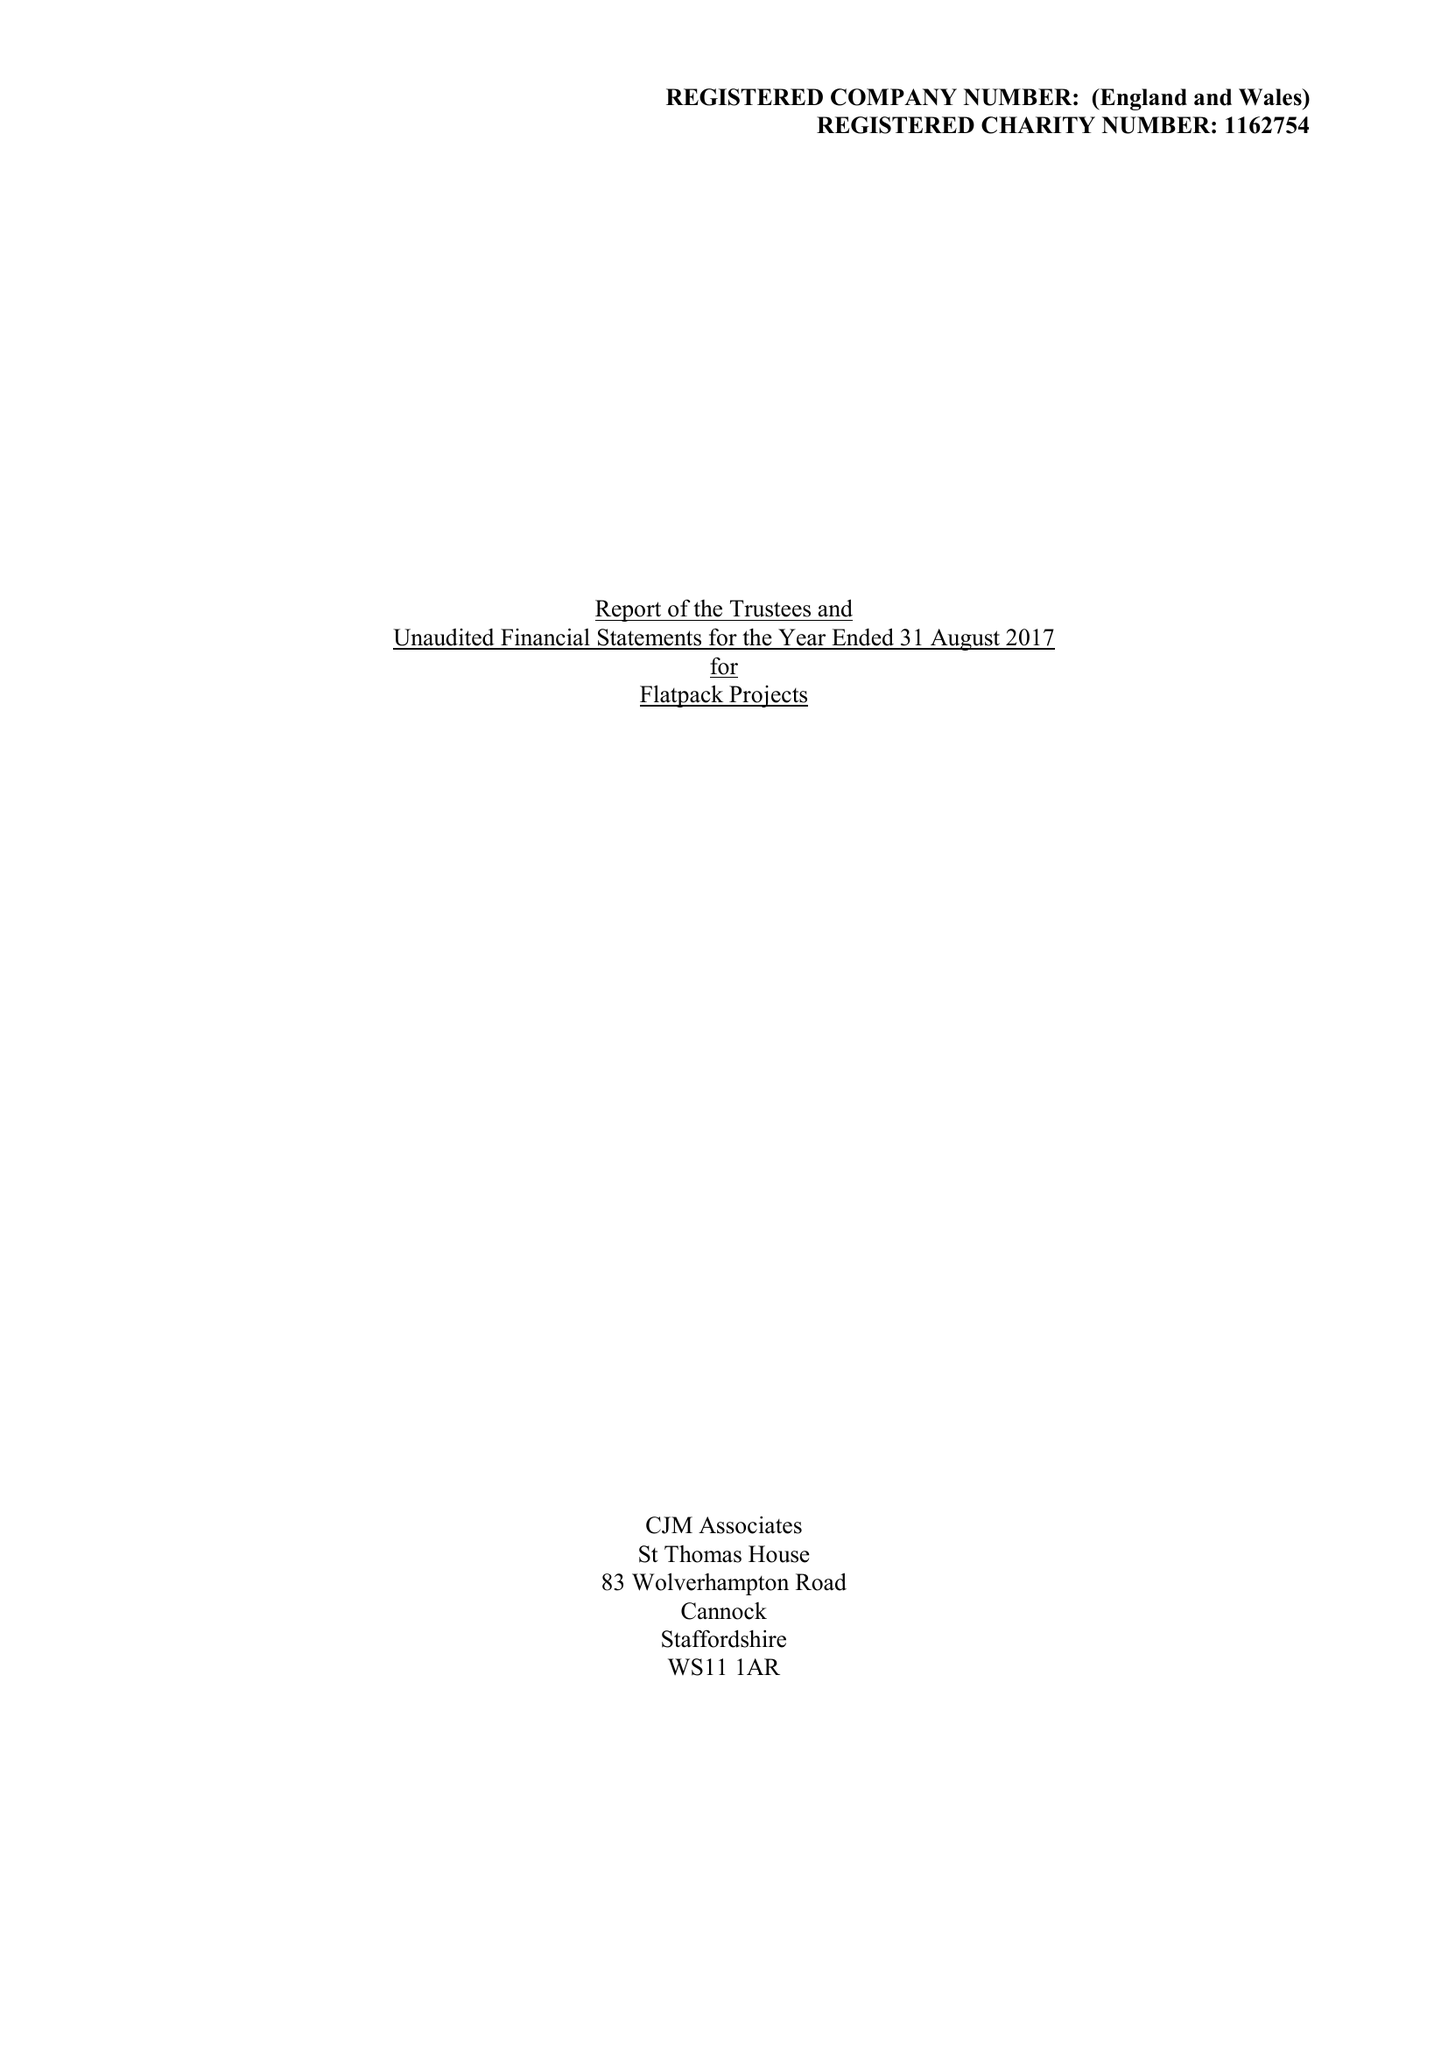What is the value for the address__street_line?
Answer the question using a single word or phrase. GIBB STREET 